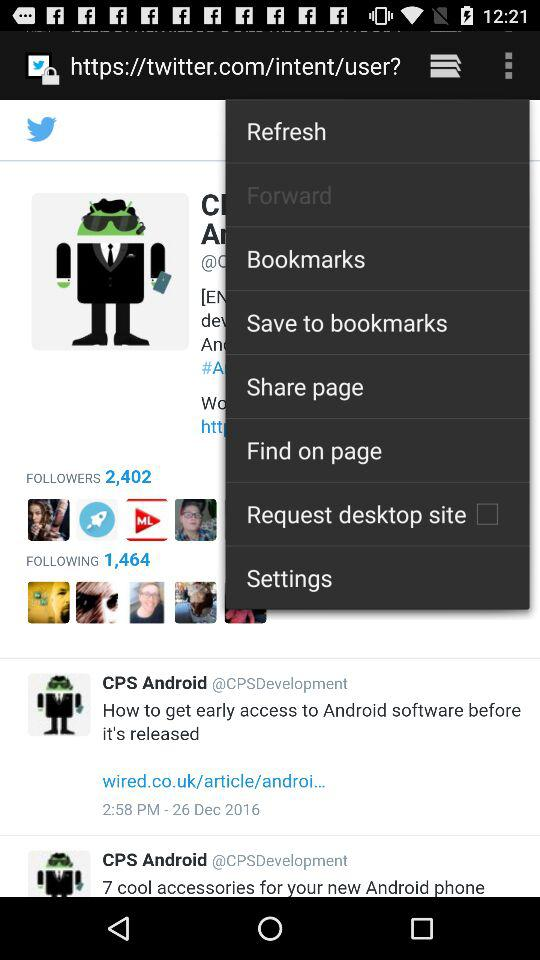What comment is posted at 2:58 PM? The comment is "How to get early access to Android software before it's released". 